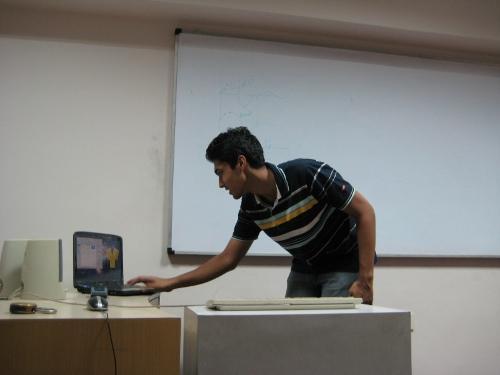How many skateboards are in the picture?
Give a very brief answer. 0. How many zebras are in the picture?
Give a very brief answer. 0. 